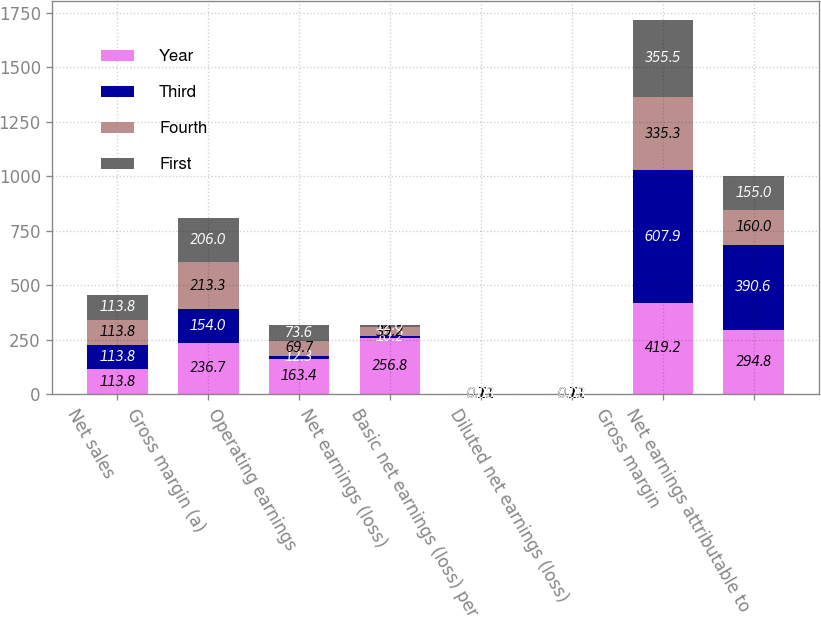<chart> <loc_0><loc_0><loc_500><loc_500><stacked_bar_chart><ecel><fcel>Net sales<fcel>Gross margin (a)<fcel>Operating earnings<fcel>Net earnings (loss)<fcel>Basic net earnings (loss) per<fcel>Diluted net earnings (loss)<fcel>Gross margin<fcel>Net earnings attributable to<nl><fcel>Year<fcel>113.8<fcel>236.7<fcel>163.4<fcel>256.8<fcel>0.73<fcel>0.73<fcel>419.2<fcel>294.8<nl><fcel>Third<fcel>113.8<fcel>154<fcel>12.3<fcel>10.2<fcel>0.03<fcel>0.03<fcel>607.9<fcel>390.6<nl><fcel>Fourth<fcel>113.8<fcel>213.3<fcel>69.7<fcel>39.2<fcel>0.11<fcel>0.11<fcel>335.3<fcel>160<nl><fcel>First<fcel>113.8<fcel>206<fcel>73.6<fcel>12<fcel>0.03<fcel>0.03<fcel>355.5<fcel>155<nl></chart> 